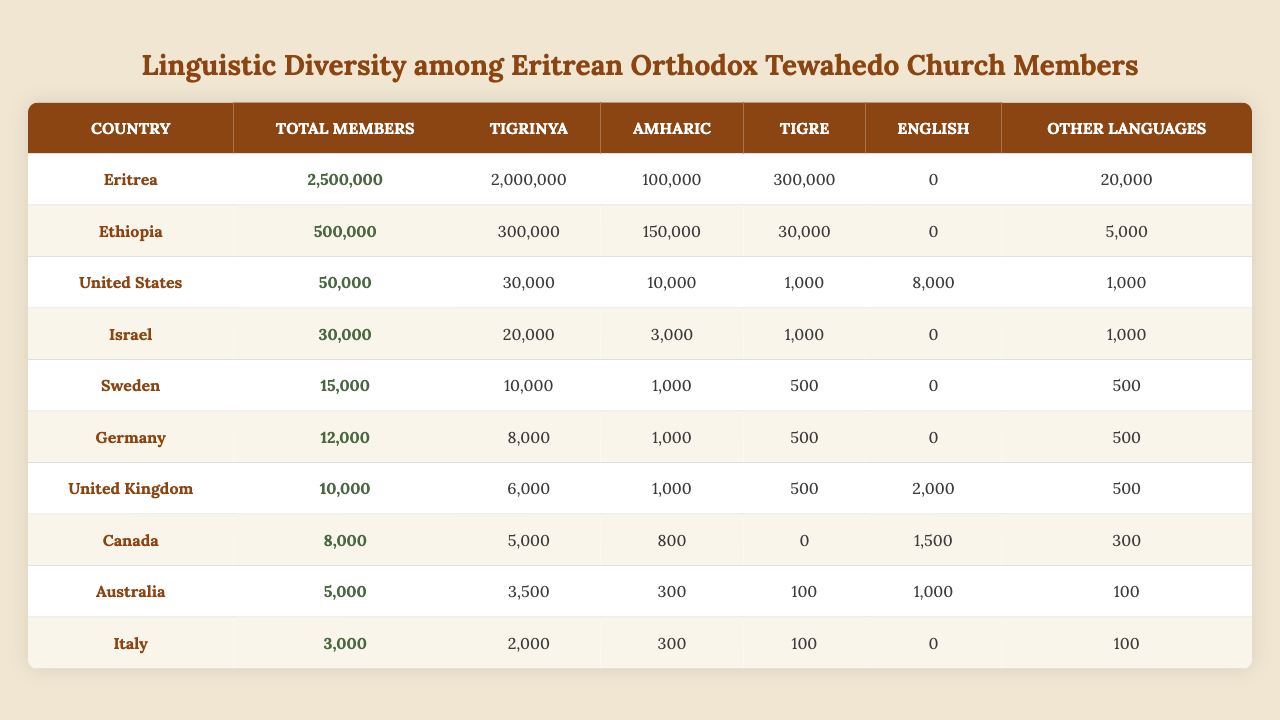What is the total number of Eritrean Orthodox Tewahedo Church members in Eritrea? According to the table, the total number of members in Eritrea is listed as 2,500,000.
Answer: 2,500,000 How many Tigrinya speakers are there among Eritrean Orthodox Tewahedo Church members in the United States? The table shows that there are 30,000 Tigrinya speakers in the United States among the members of the church.
Answer: 30,000 Which country has the highest number of Amharic speakers in the Eritrean Orthodox Tewahedo Church? By comparing the Amharic speakers across all countries listed, Ethiopia has the highest number with 150,000 speakers.
Answer: Ethiopia What is the total number of Tigrinya speakers across all the countries listed? The total can be calculated by summing the Tigrinya speakers in each country: 2,000,000 (Eritrea) + 300,000 (Ethiopia) + 30,000 (USA) + 20,000 (Israel) + 10,000 (Sweden) + 8,000 (Germany) + 6,000 (UK) + 5,000 (Canada) + 3,500 (Australia) + 2,000 (Italy) = 2,384,500.
Answer: 2,384,500 Is the number of Tigre speakers in Canada greater than the number of Amharic speakers in Australia? In Canada, there are 0 Tigre speakers and in Australia, there are 300 Amharic speakers. Since 0 is not greater than 300, the answer is no.
Answer: No What percentage of the total members in the United Kingdom speak Tigrinya? The total number of members in the UK is 10,000, with 6,000 of them being Tigrinya speakers. The percentage is calculated as (6,000 / 10,000) * 100 = 60%.
Answer: 60% Which country has the lowest number of total members and how many are there? The table shows Italy with the lowest number of total members at 3,000.
Answer: Italy, 3,000 What is the difference in total members between Eritrea and Canada? The total members in Eritrea are 2,500,000 and in Canada, they are 8,000. The difference is 2,500,000 - 8,000 = 2,492,000.
Answer: 2,492,000 How many members are there in Israel compared to Australia? Israel has 30,000 members and Australia has 5,000 members. Therefore, Israel has 30,000 - 5,000 = 25,000 more members than Australia.
Answer: 25,000 Are the total members in Sweden and Germany combined greater than or equal to the total members in the United States? Sweden has 15,000 members and Germany has 12,000. Combined, they have 15,000 + 12,000 = 27,000, which is greater than the 50,000 members in the United States.
Answer: Yes 